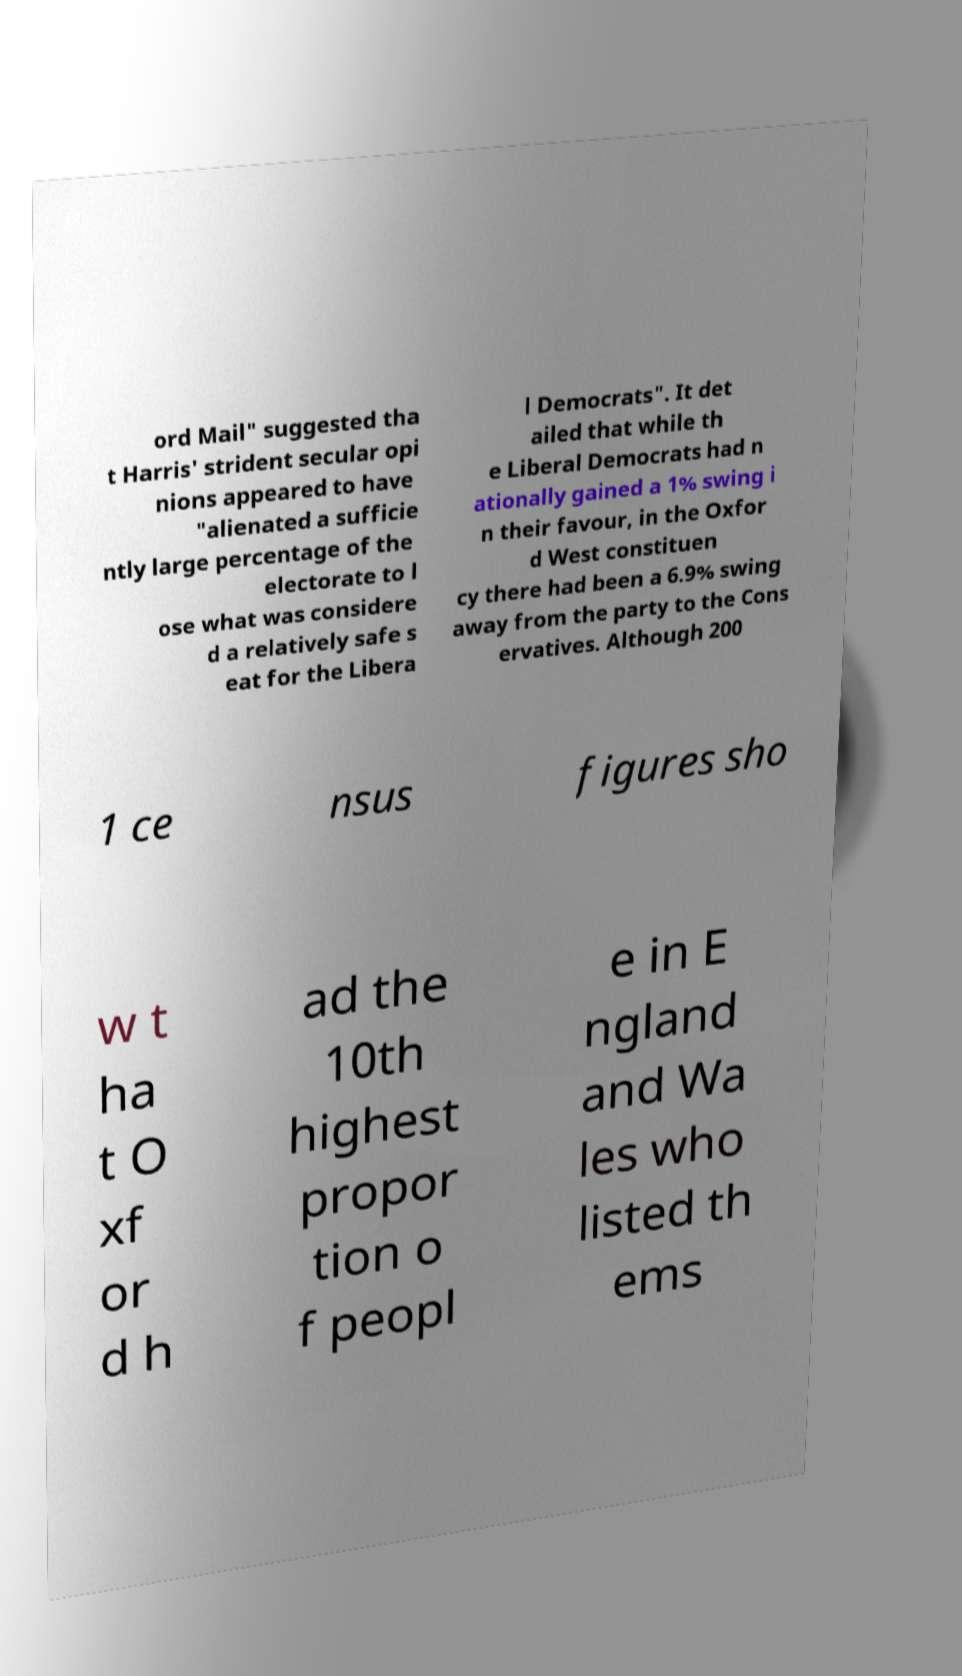Please identify and transcribe the text found in this image. ord Mail" suggested tha t Harris' strident secular opi nions appeared to have "alienated a sufficie ntly large percentage of the electorate to l ose what was considere d a relatively safe s eat for the Libera l Democrats". It det ailed that while th e Liberal Democrats had n ationally gained a 1% swing i n their favour, in the Oxfor d West constituen cy there had been a 6.9% swing away from the party to the Cons ervatives. Although 200 1 ce nsus figures sho w t ha t O xf or d h ad the 10th highest propor tion o f peopl e in E ngland and Wa les who listed th ems 